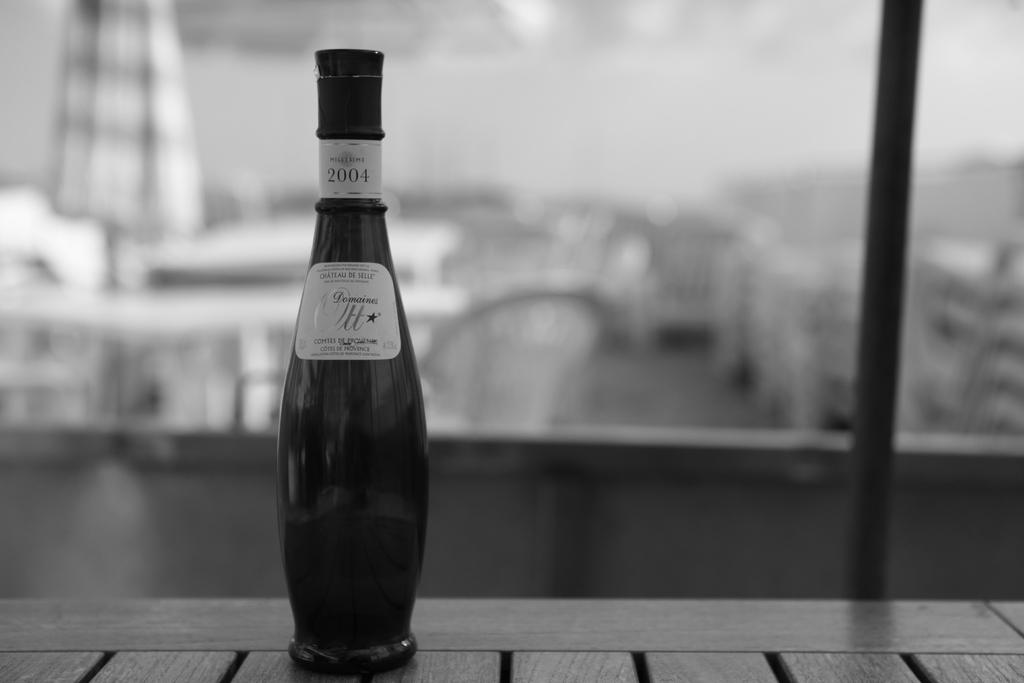<image>
Offer a succinct explanation of the picture presented. A slender bottle dated 2004 sits on a table. 